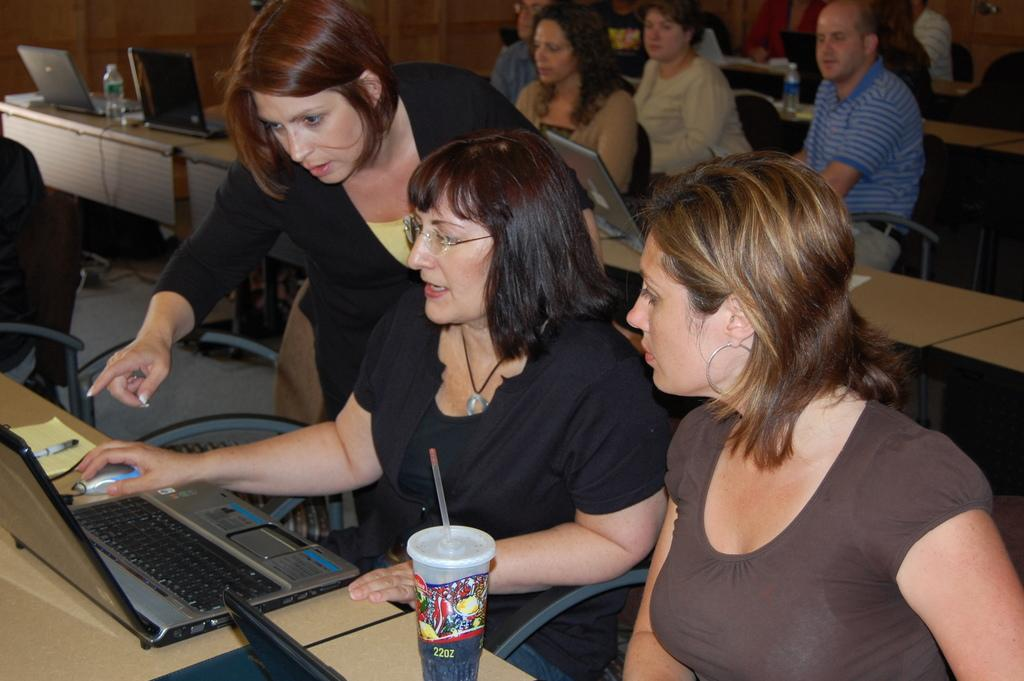What type of seating is available in the image? There are benches and chairs in the image. Who is using the seating in the image? People are sitting on the chairs. What items are placed on the benches? There are laptops, mouses, and glasses on the bench. What type of account is being discussed on the bench? There is no mention of an account in the image; it features benches, chairs, and various items. What type of plastic material is present in the image? There is no specific plastic material mentioned in the image; it features benches, chairs, and various items, but no plastic items are explicitly mentioned. 